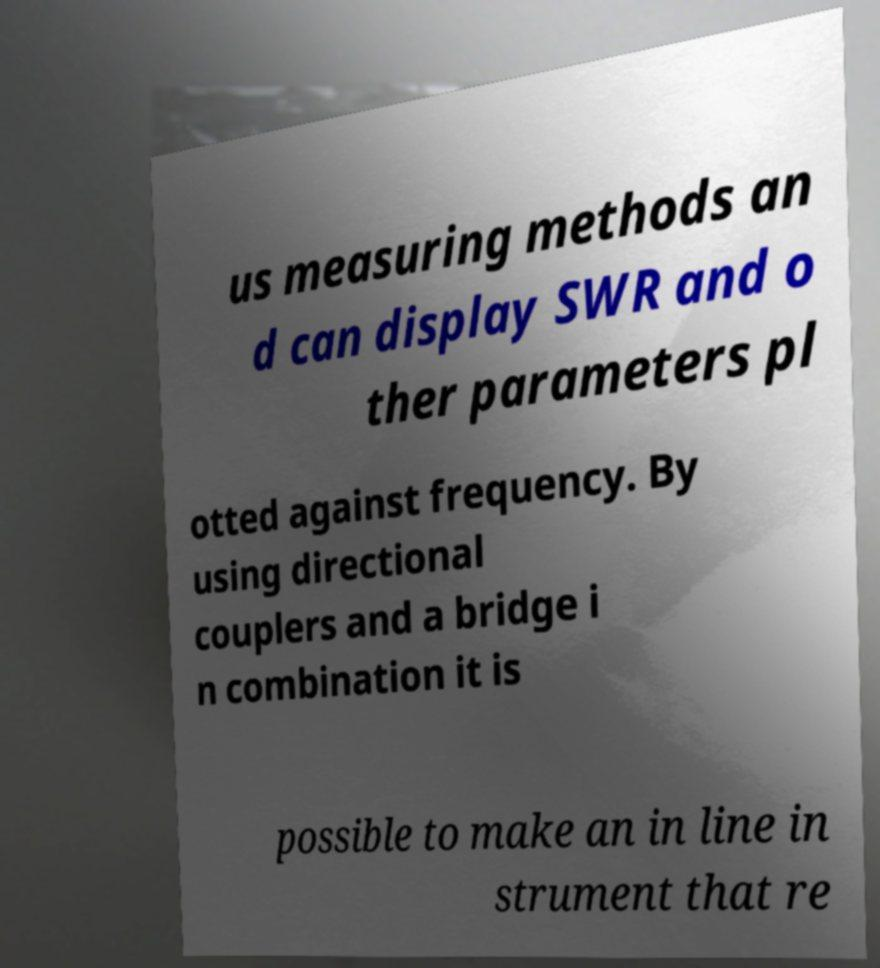There's text embedded in this image that I need extracted. Can you transcribe it verbatim? us measuring methods an d can display SWR and o ther parameters pl otted against frequency. By using directional couplers and a bridge i n combination it is possible to make an in line in strument that re 